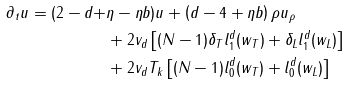<formula> <loc_0><loc_0><loc_500><loc_500>\partial _ { t } u = ( 2 - d + & \eta - \eta b ) u + \left ( d - 4 + \eta b \right ) \rho u _ { \rho } \\ & + 2 v _ { d } \left [ ( N - 1 ) \delta _ { T } l _ { 1 } ^ { d } ( w _ { T } ) + \delta _ { L } l _ { 1 } ^ { d } ( w _ { L } ) \right ] \\ & + 2 v _ { d } T _ { k } \left [ ( N - 1 ) l _ { 0 } ^ { d } ( w _ { T } ) + l _ { 0 } ^ { d } ( w _ { L } ) \right ]</formula> 